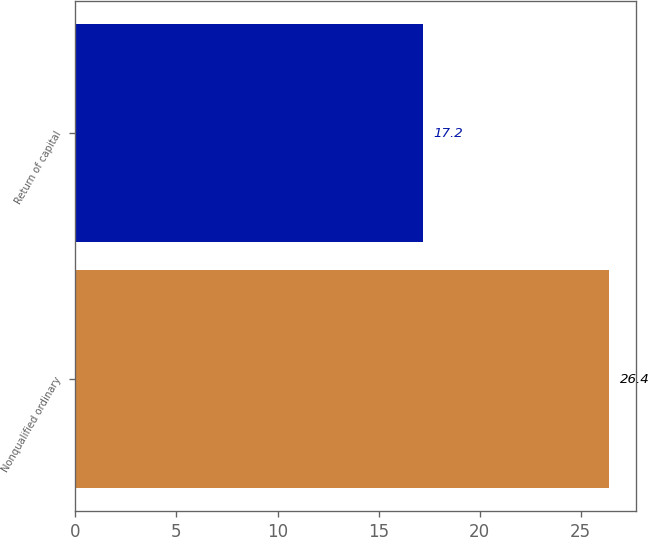Convert chart to OTSL. <chart><loc_0><loc_0><loc_500><loc_500><bar_chart><fcel>Nonqualified ordinary<fcel>Return of capital<nl><fcel>26.4<fcel>17.2<nl></chart> 